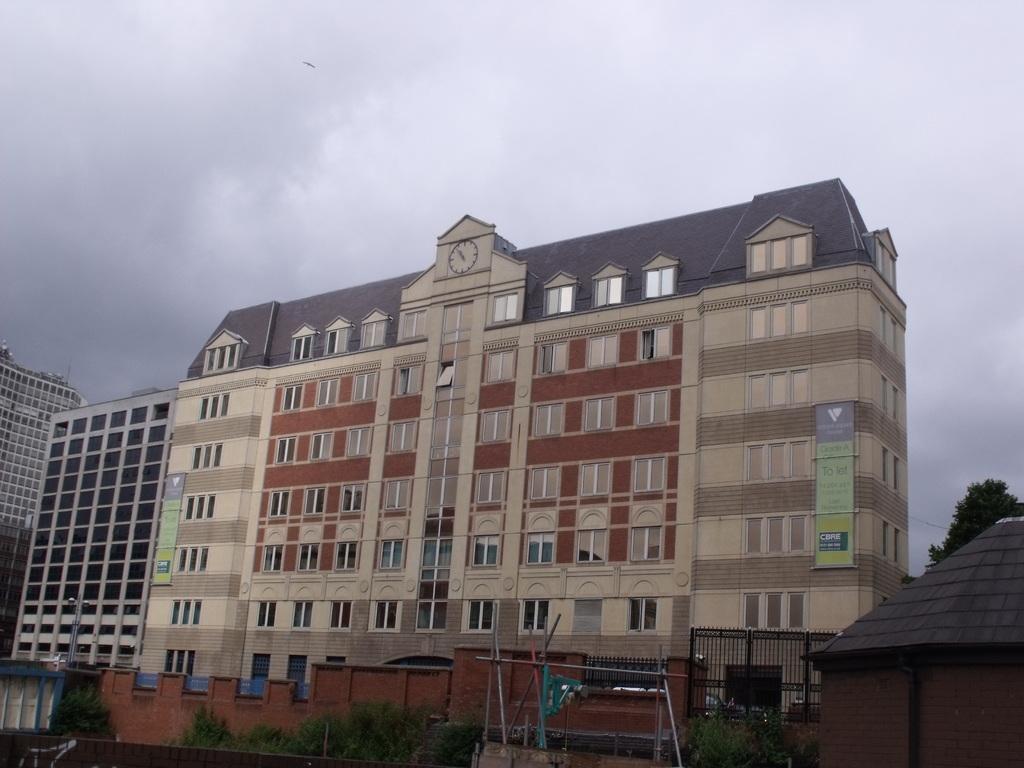Could you give a brief overview of what you see in this image? In this image there are buildings, trees. In front of the buildings there is a compound wall with a metal gate, in front of the compound wall there are plants and some wooden sticks. 